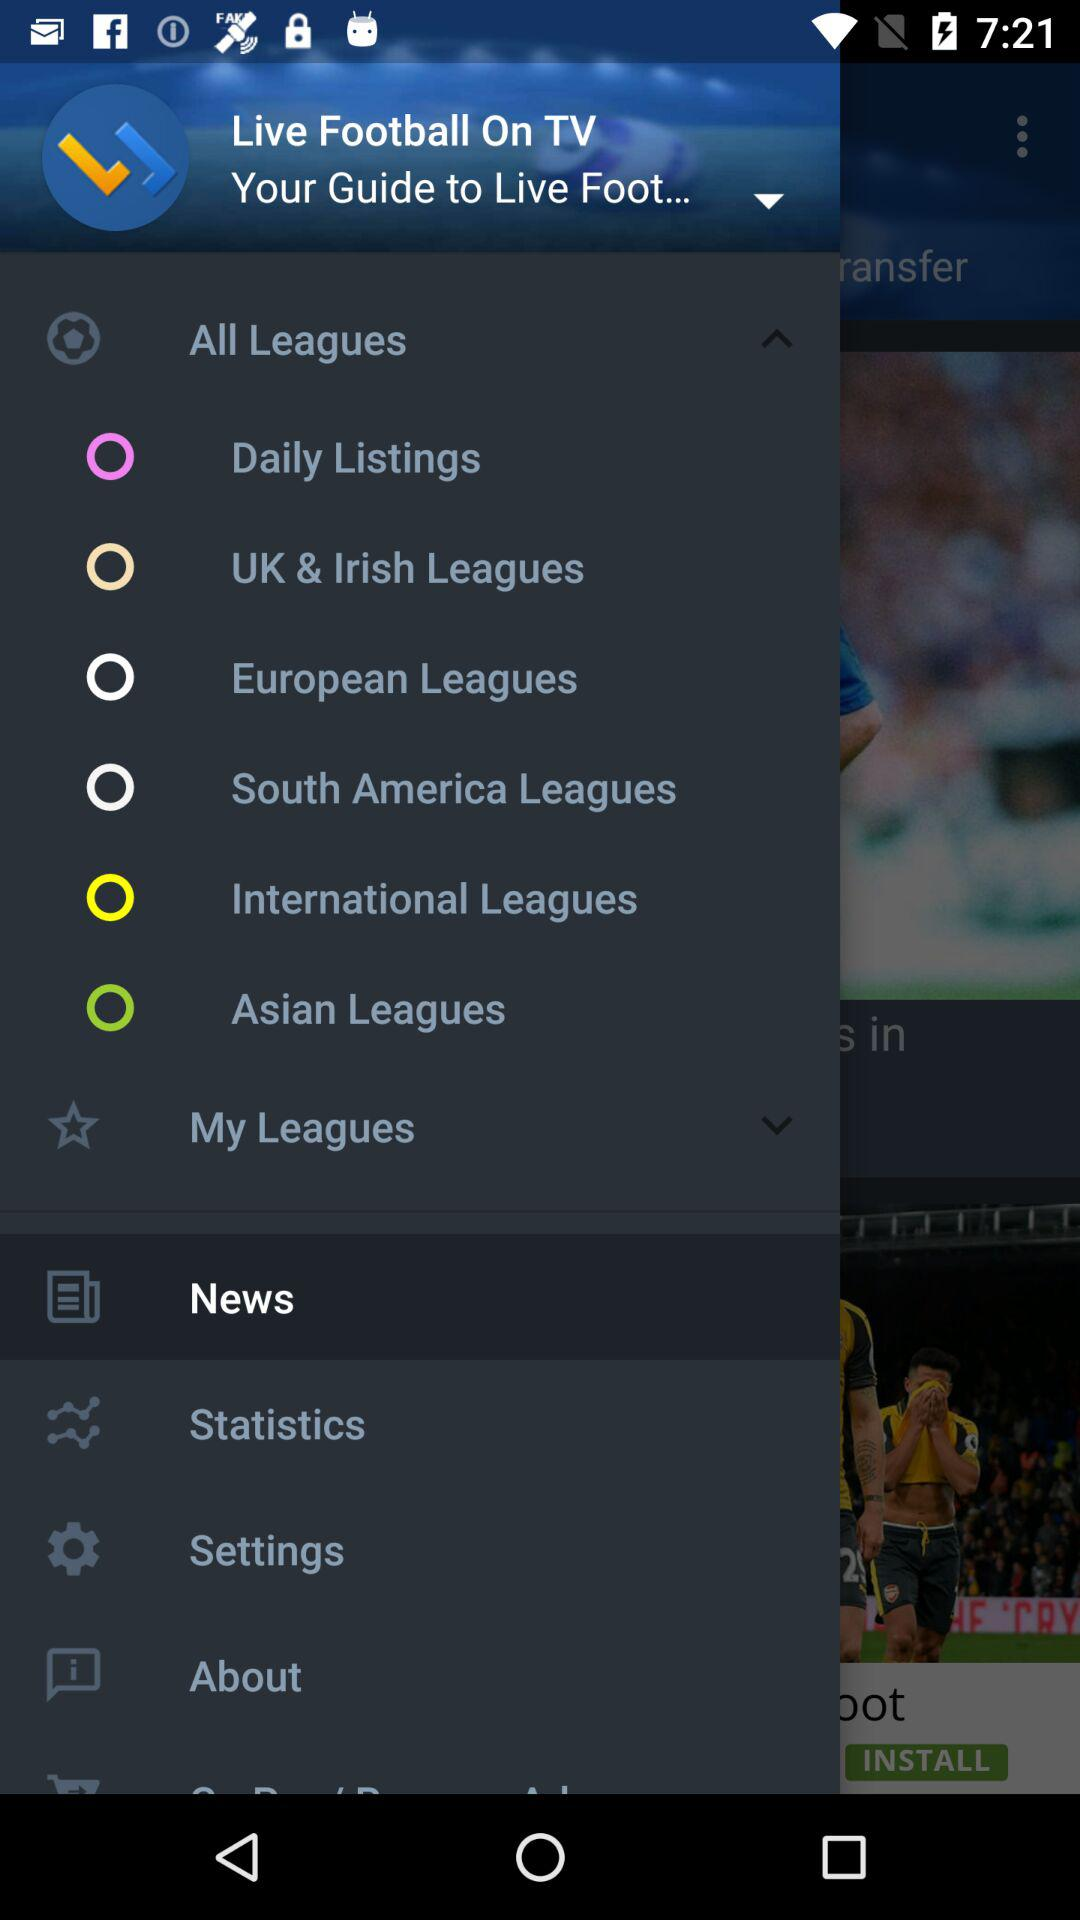What is the name of the application? The name of the application is "Live Football On TV". 